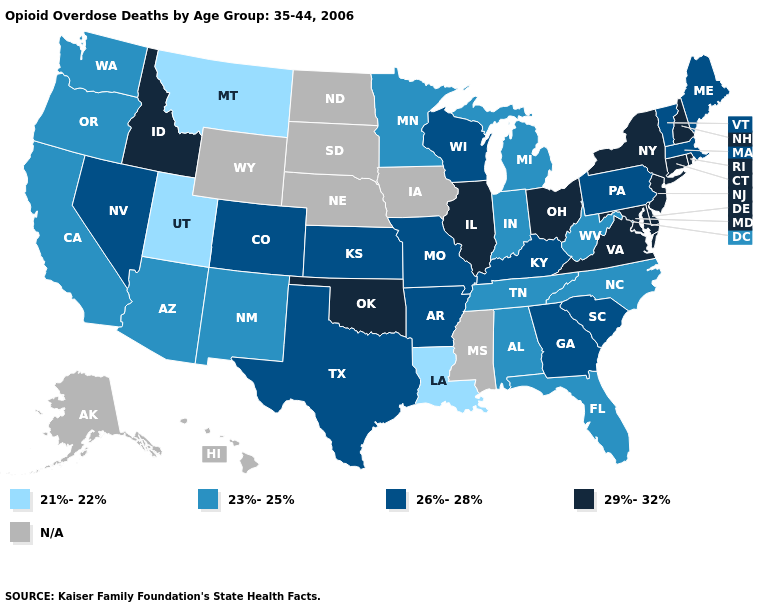What is the value of Tennessee?
Give a very brief answer. 23%-25%. Name the states that have a value in the range 23%-25%?
Be succinct. Alabama, Arizona, California, Florida, Indiana, Michigan, Minnesota, New Mexico, North Carolina, Oregon, Tennessee, Washington, West Virginia. What is the value of Alabama?
Keep it brief. 23%-25%. Does Arkansas have the lowest value in the South?
Be succinct. No. Which states have the highest value in the USA?
Be succinct. Connecticut, Delaware, Idaho, Illinois, Maryland, New Hampshire, New Jersey, New York, Ohio, Oklahoma, Rhode Island, Virginia. Name the states that have a value in the range 21%-22%?
Concise answer only. Louisiana, Montana, Utah. Does Maryland have the highest value in the USA?
Answer briefly. Yes. Name the states that have a value in the range 26%-28%?
Give a very brief answer. Arkansas, Colorado, Georgia, Kansas, Kentucky, Maine, Massachusetts, Missouri, Nevada, Pennsylvania, South Carolina, Texas, Vermont, Wisconsin. Name the states that have a value in the range 29%-32%?
Answer briefly. Connecticut, Delaware, Idaho, Illinois, Maryland, New Hampshire, New Jersey, New York, Ohio, Oklahoma, Rhode Island, Virginia. Does the first symbol in the legend represent the smallest category?
Concise answer only. Yes. Does Utah have the lowest value in the USA?
Write a very short answer. Yes. Name the states that have a value in the range 21%-22%?
Be succinct. Louisiana, Montana, Utah. What is the highest value in the USA?
Be succinct. 29%-32%. What is the value of Maine?
Short answer required. 26%-28%. Name the states that have a value in the range N/A?
Concise answer only. Alaska, Hawaii, Iowa, Mississippi, Nebraska, North Dakota, South Dakota, Wyoming. 